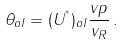<formula> <loc_0><loc_0><loc_500><loc_500>\theta _ { a I } = ( U ^ { ^ { * } } ) _ { a I } \frac { v p } { v _ { R } } \, .</formula> 